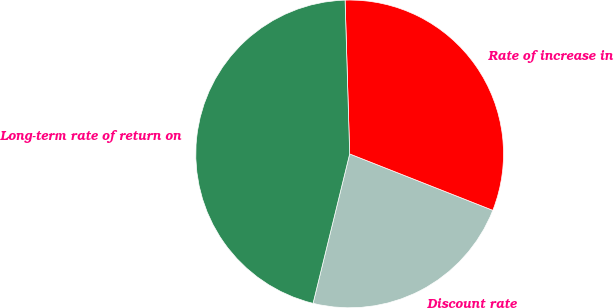Convert chart to OTSL. <chart><loc_0><loc_0><loc_500><loc_500><pie_chart><fcel>Discount rate<fcel>Rate of increase in<fcel>Long-term rate of return on<nl><fcel>22.85%<fcel>31.45%<fcel>45.7%<nl></chart> 